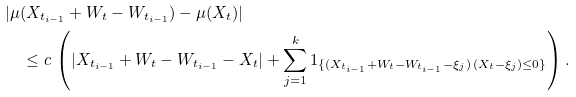Convert formula to latex. <formula><loc_0><loc_0><loc_500><loc_500>& | \mu ( X _ { t _ { i - 1 } } + W _ { t } - W _ { t _ { i - 1 } } ) - \mu ( X _ { t } ) | \\ & \quad \leq c \, \left ( | X _ { t _ { i - 1 } } + W _ { t } - W _ { t _ { i - 1 } } - X _ { t } | + \sum _ { j = 1 } ^ { k } 1 _ { \{ ( X _ { t _ { i - 1 } } + W _ { t } - W _ { t _ { i - 1 } } - \xi _ { j } ) \, ( X _ { t } - \xi _ { j } ) \leq 0 \} } \right ) .</formula> 